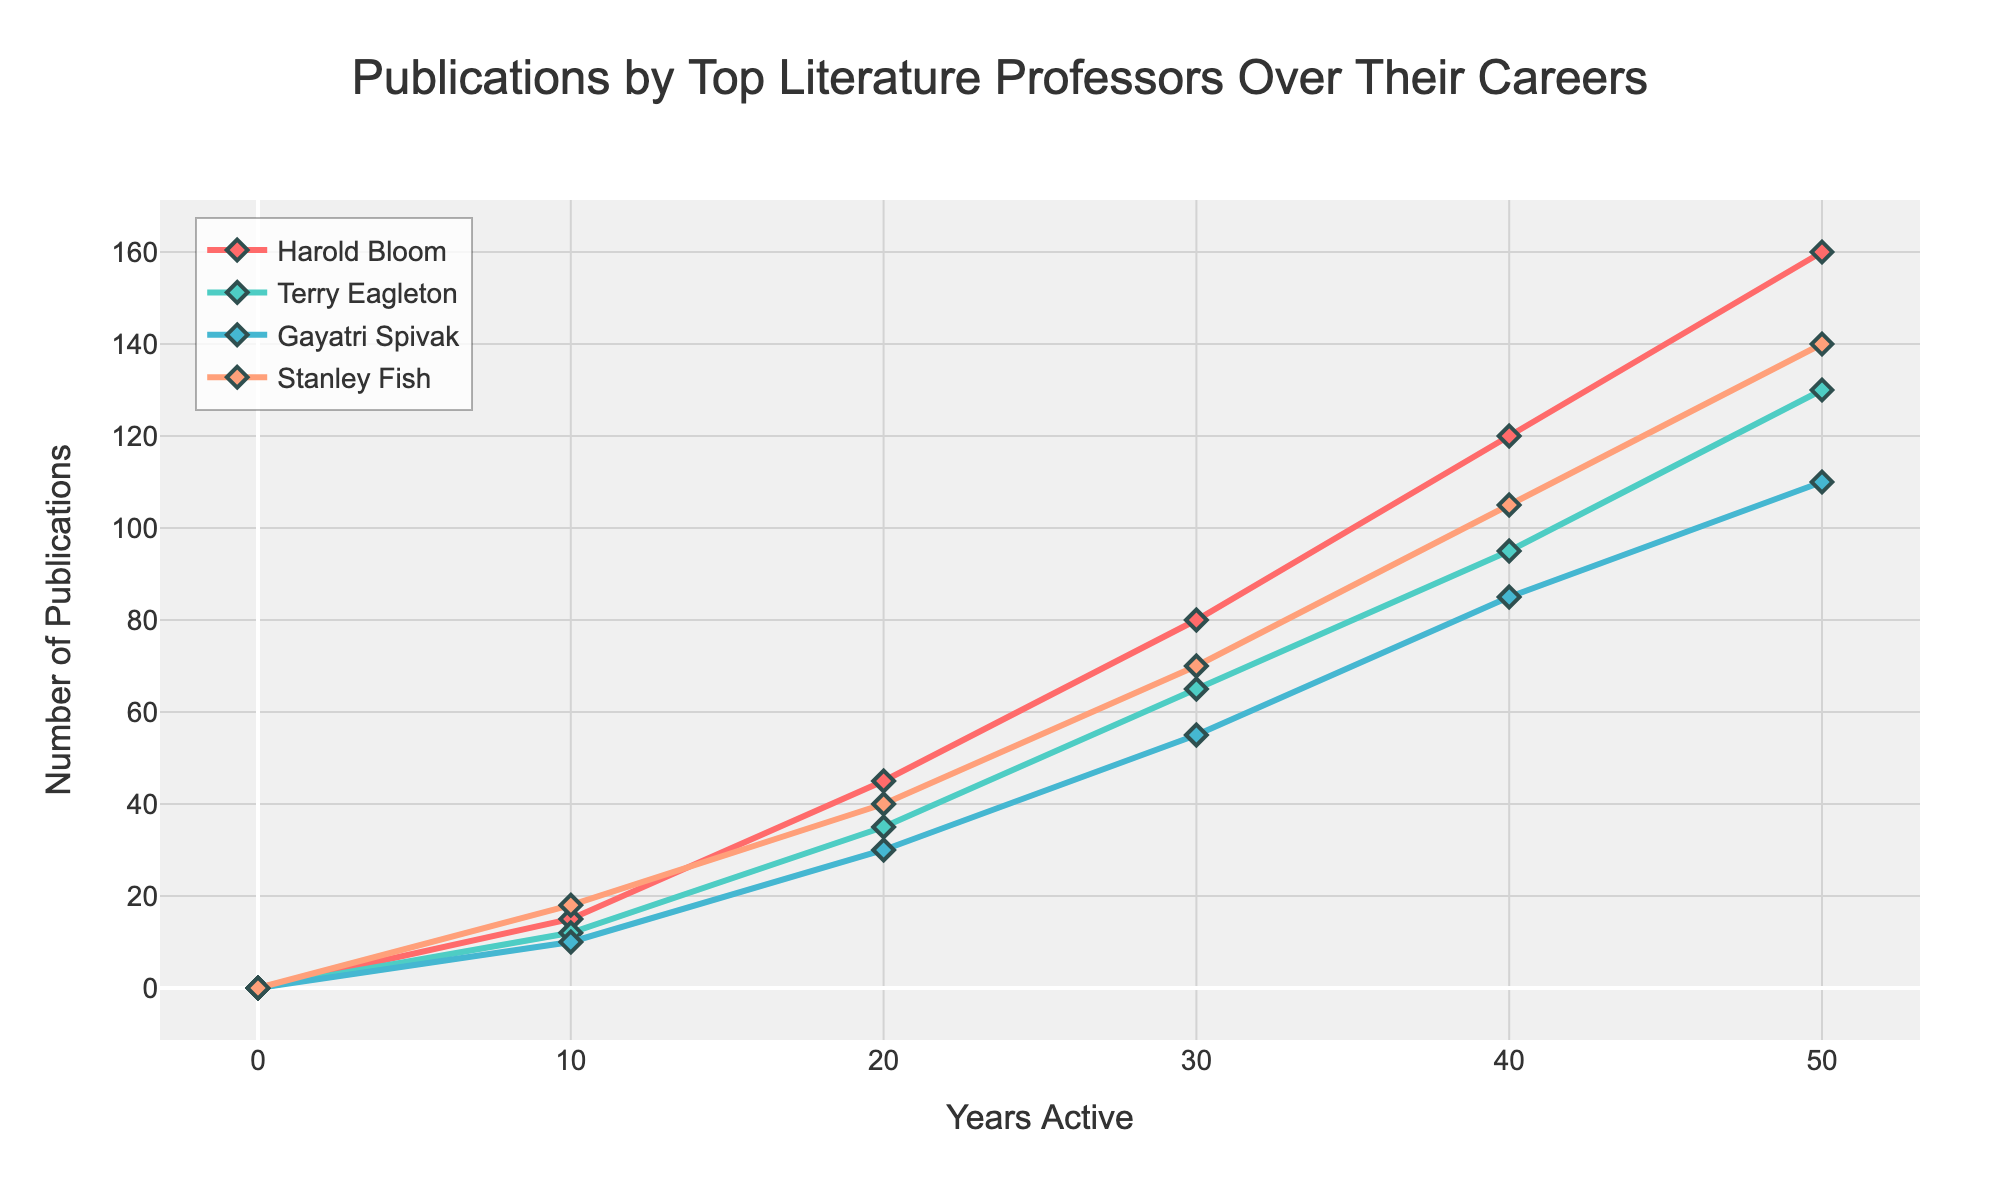Which professor had the most publications after 20 years? Look at the publication numbers for each professor at the 20-year mark. Harold Bloom had 45, Terry Eagleton had 35, Gayatri Spivak had 30, and Stanley Fish had 40. Harold Bloom had the most publications at 20 years.
Answer: Harold Bloom Whose publication count increased the fastest between year 0 and year 10? Calculate the increase in publications for each professor between year 0 and year 10: Harold Bloom (15 - 0 = 15), Terry Eagleton (12 - 0 = 12), Gayatri Spivak (10 - 0 = 10), Stanley Fish (18 - 0 = 18). Stanley Fish had the highest increase.
Answer: Stanley Fish How many publications did Terry Eagleton have after 30 years compared to Gayatri Spivak? Look at the publication numbers for Terry Eagleton and Gayatri Spivak at the 30-year mark: Terry Eagleton had 65 publications, and Gayatri Spivak had 55. Terry Eagleton had 10 more publications than Gayatri Spivak after 30 years.
Answer: 10 more What is the average number of publications Harold Bloom had every decade? Harold Bloom's publication counts at each decade are 0, 15, 45, 80, 120, and 160. To find the average, sum the values and divide by the number of decades: (0 + 15 + 45 + 80 + 120 + 160) / 6 = 70.
Answer: 70 Which professor had the most significant increase in publications between year 30 and year 50? Calculate the increase in publications for each professor between year 30 and year 50: Harold Bloom (160 - 80 = 80), Terry Eagleton (130 - 65 = 65), Gayatri Spivak (110 - 55 = 55), Stanley Fish (140 - 70 = 70). Harold Bloom had the most significant increase.
Answer: Harold Bloom At the 40-year mark, which two professors had the closest number of publications? Look at the publication numbers for each professor at the 40-year mark: Harold Bloom (120), Terry Eagleton (95), Gayatri Spivak (85), and Stanley Fish (105). Gayatri Spivak and Terry Eagleton had the closest numbers, with a difference of 10.
Answer: Gayatri Spivak and Terry Eagleton What is the total number of publications by all professors at the 50-year mark? Sum the publication numbers for all professors at the 50-year mark: Harold Bloom (160), Terry Eagleton (130), Gayatri Spivak (110), and Stanley Fish (140). The total is 160 + 130 + 110 + 140 = 540.
Answer: 540 Which professor's publication trend appears the most linear? By observing the publication plot for each professor, Gayatri Spivak's publication trend appears to be the most linear or consistent over the years without much deviation.
Answer: Gayatri Spivak 